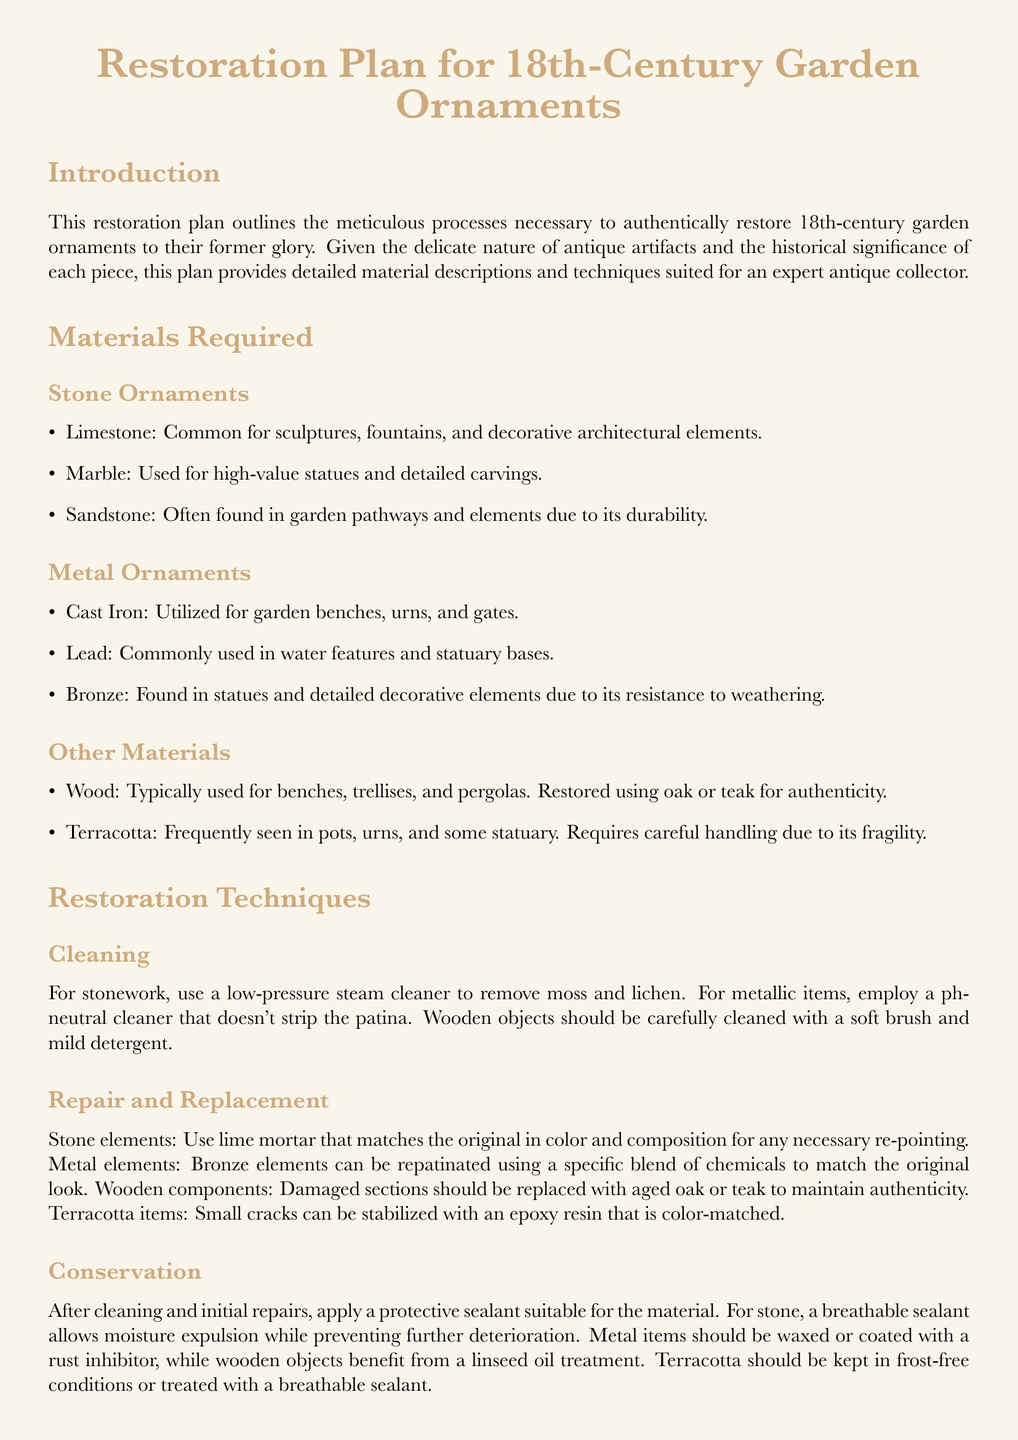What is the purpose of the document? The document outlines the meticulous processes necessary to authentically restore 18th-century garden ornaments.
Answer: Restoration plan What type of sealant is recommended for stone ornaments? A breathable sealant is suggested for stone to allow moisture expulsion.
Answer: Breathable sealant What materials are specified for wooden components? The document specifies aged oak or teak to maintain authenticity in wooden restoration.
Answer: Oak or teak What should be used for cleaning metallic items? A ph-neutral cleaner is recommended for cleaning metallic items without stripping patina.
Answer: Ph-neutral cleaner Which metal is commonly used for water features? The document mentions lead as a commonly used metal for water features.
Answer: Lead What is done to stabilize small cracks in terracotta? Small cracks in terracotta can be stabilized with color-matched epoxy resin.
Answer: Epoxy resin What is the technique used to remove moss and lichen from stonework? Low-pressure steam cleaner is the recommended technique for cleaning stonework.
Answer: Low-pressure steam cleaner How are bronze elements repaired? Bronze elements can be repatinated using a specific blend of chemicals.
Answer: Repatinated What final touch is suggested for faded areas? The document suggests repainting faded areas using historical color palettes.
Answer: Historical color palettes 